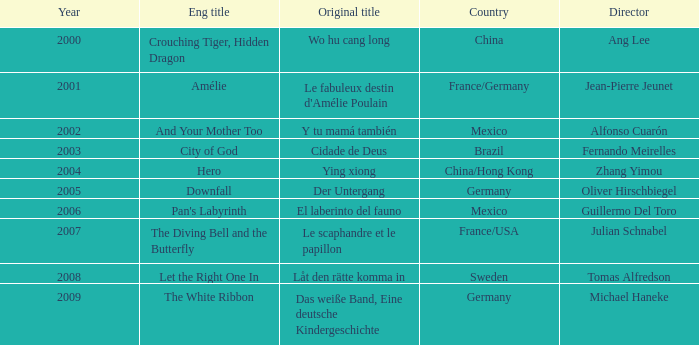Name the title of jean-pierre jeunet Amélie. 